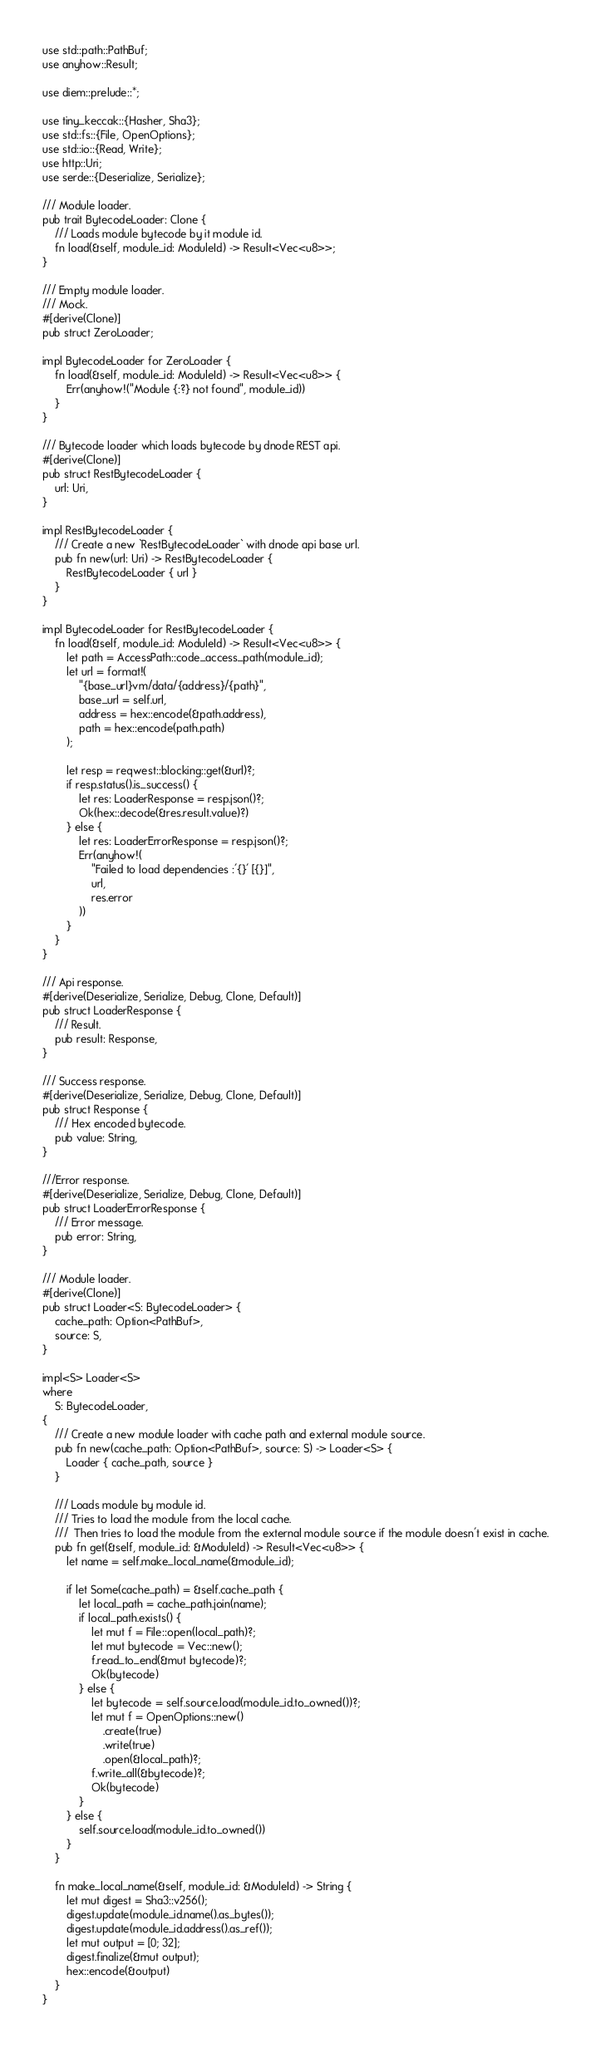<code> <loc_0><loc_0><loc_500><loc_500><_Rust_>use std::path::PathBuf;
use anyhow::Result;

use diem::prelude::*;

use tiny_keccak::{Hasher, Sha3};
use std::fs::{File, OpenOptions};
use std::io::{Read, Write};
use http::Uri;
use serde::{Deserialize, Serialize};

/// Module loader.
pub trait BytecodeLoader: Clone {
    /// Loads module bytecode by it module id.
    fn load(&self, module_id: ModuleId) -> Result<Vec<u8>>;
}

/// Empty module loader.
/// Mock.
#[derive(Clone)]
pub struct ZeroLoader;

impl BytecodeLoader for ZeroLoader {
    fn load(&self, module_id: ModuleId) -> Result<Vec<u8>> {
        Err(anyhow!("Module {:?} not found", module_id))
    }
}

/// Bytecode loader which loads bytecode by dnode REST api.
#[derive(Clone)]
pub struct RestBytecodeLoader {
    url: Uri,
}

impl RestBytecodeLoader {
    /// Create a new `RestBytecodeLoader` with dnode api base url.
    pub fn new(url: Uri) -> RestBytecodeLoader {
        RestBytecodeLoader { url }
    }
}

impl BytecodeLoader for RestBytecodeLoader {
    fn load(&self, module_id: ModuleId) -> Result<Vec<u8>> {
        let path = AccessPath::code_access_path(module_id);
        let url = format!(
            "{base_url}vm/data/{address}/{path}",
            base_url = self.url,
            address = hex::encode(&path.address),
            path = hex::encode(path.path)
        );

        let resp = reqwest::blocking::get(&url)?;
        if resp.status().is_success() {
            let res: LoaderResponse = resp.json()?;
            Ok(hex::decode(&res.result.value)?)
        } else {
            let res: LoaderErrorResponse = resp.json()?;
            Err(anyhow!(
                "Failed to load dependencies :'{}' [{}]",
                url,
                res.error
            ))
        }
    }
}

/// Api response.
#[derive(Deserialize, Serialize, Debug, Clone, Default)]
pub struct LoaderResponse {
    /// Result.
    pub result: Response,
}

/// Success response.
#[derive(Deserialize, Serialize, Debug, Clone, Default)]
pub struct Response {
    /// Hex encoded bytecode.
    pub value: String,
}

///Error response.
#[derive(Deserialize, Serialize, Debug, Clone, Default)]
pub struct LoaderErrorResponse {
    /// Error message.
    pub error: String,
}

/// Module loader.
#[derive(Clone)]
pub struct Loader<S: BytecodeLoader> {
    cache_path: Option<PathBuf>,
    source: S,
}

impl<S> Loader<S>
where
    S: BytecodeLoader,
{
    /// Create a new module loader with cache path and external module source.
    pub fn new(cache_path: Option<PathBuf>, source: S) -> Loader<S> {
        Loader { cache_path, source }
    }

    /// Loads module by module id.
    /// Tries to load the module from the local cache.
    ///  Then tries to load the module from the external module source if the module doesn't exist in cache.
    pub fn get(&self, module_id: &ModuleId) -> Result<Vec<u8>> {
        let name = self.make_local_name(&module_id);

        if let Some(cache_path) = &self.cache_path {
            let local_path = cache_path.join(name);
            if local_path.exists() {
                let mut f = File::open(local_path)?;
                let mut bytecode = Vec::new();
                f.read_to_end(&mut bytecode)?;
                Ok(bytecode)
            } else {
                let bytecode = self.source.load(module_id.to_owned())?;
                let mut f = OpenOptions::new()
                    .create(true)
                    .write(true)
                    .open(&local_path)?;
                f.write_all(&bytecode)?;
                Ok(bytecode)
            }
        } else {
            self.source.load(module_id.to_owned())
        }
    }

    fn make_local_name(&self, module_id: &ModuleId) -> String {
        let mut digest = Sha3::v256();
        digest.update(module_id.name().as_bytes());
        digest.update(module_id.address().as_ref());
        let mut output = [0; 32];
        digest.finalize(&mut output);
        hex::encode(&output)
    }
}
</code> 